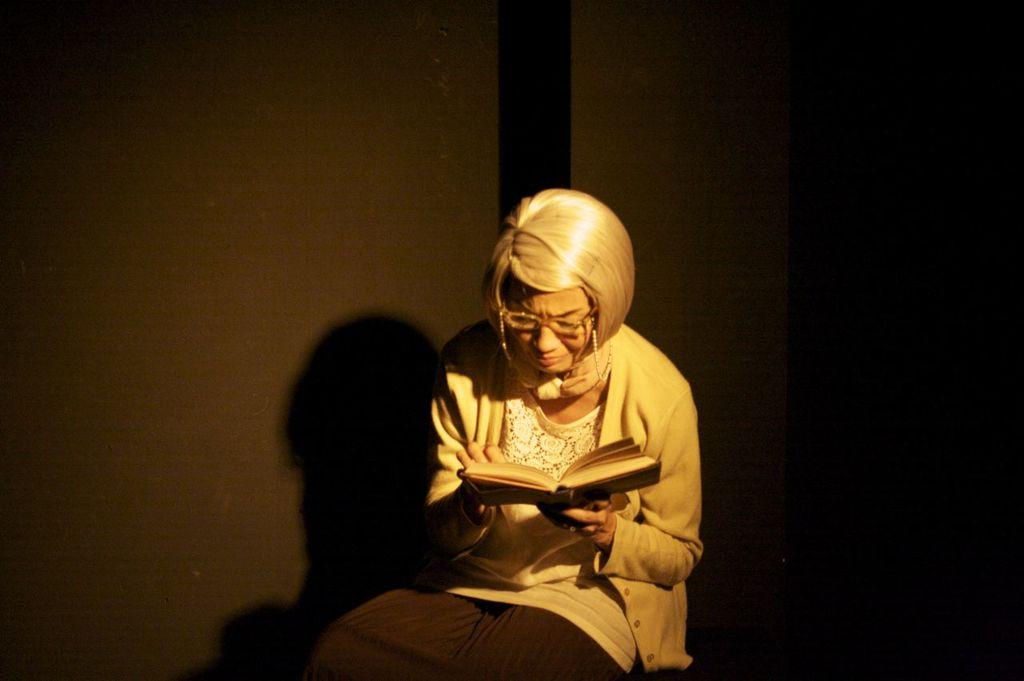Who is the main subject in the image? There is a woman in the image. What is the woman doing in the image? The woman is reading a book. How is the woman holding the book? The woman is holding the book in her hand. What can be seen behind the woman in the image? There is a wall behind the woman. What type of medical equipment can be seen near the scarecrow in the image? There is no medical equipment or scarecrow present in the image. Is there a birthday cake visible in the image? There is no birthday cake or any indication of a birthday celebration in the image. 